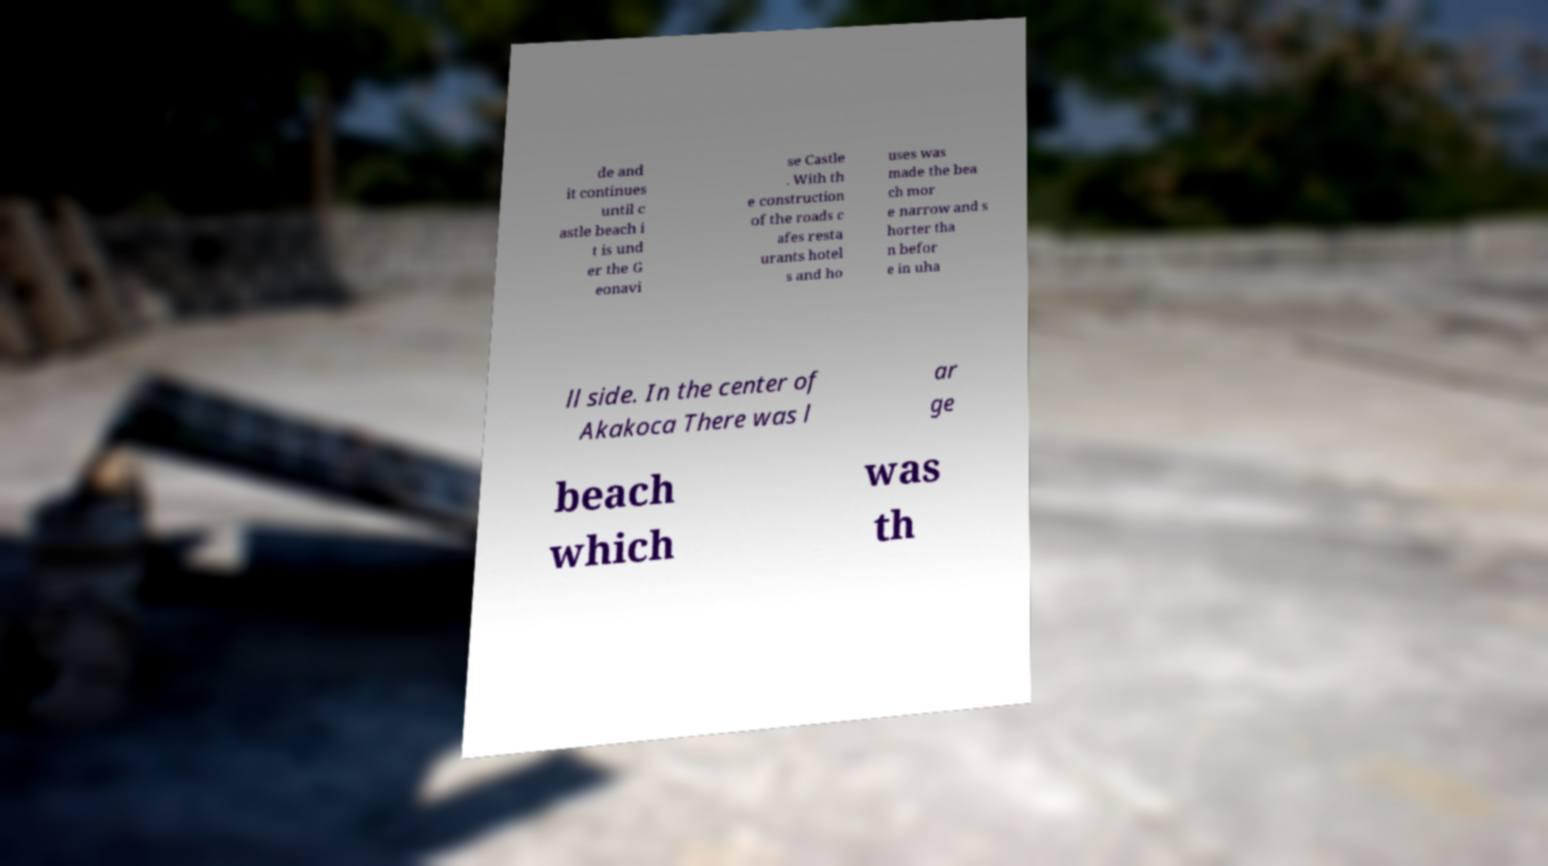Can you read and provide the text displayed in the image?This photo seems to have some interesting text. Can you extract and type it out for me? de and it continues until c astle beach i t is und er the G eonavi se Castle . With th e construction of the roads c afes resta urants hotel s and ho uses was made the bea ch mor e narrow and s horter tha n befor e in uha ll side. In the center of Akakoca There was l ar ge beach which was th 